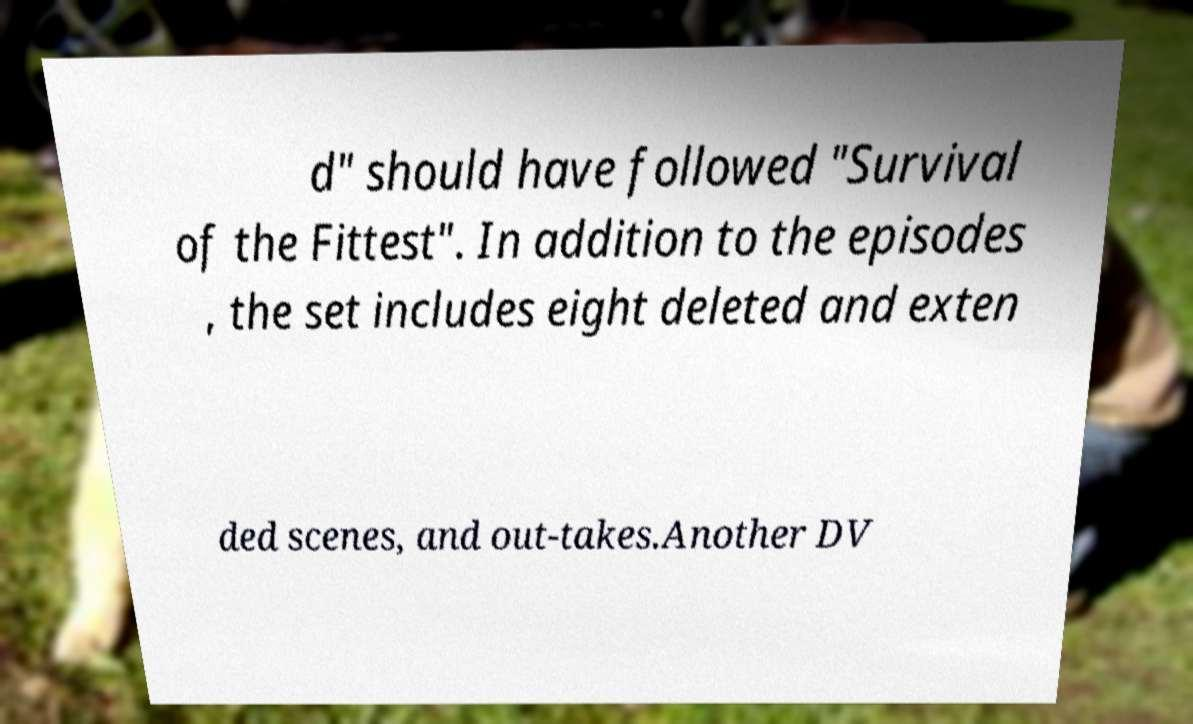Could you extract and type out the text from this image? d" should have followed "Survival of the Fittest". In addition to the episodes , the set includes eight deleted and exten ded scenes, and out-takes.Another DV 